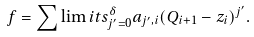<formula> <loc_0><loc_0><loc_500><loc_500>f = \sum \lim i t s _ { j ^ { \prime } = 0 } ^ { \delta } a _ { j ^ { \prime } , i } ( Q _ { i + 1 } - z _ { i } ) ^ { j ^ { \prime } } .</formula> 